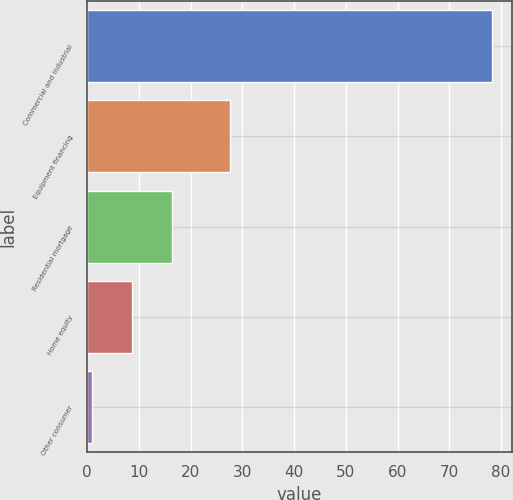Convert chart. <chart><loc_0><loc_0><loc_500><loc_500><bar_chart><fcel>Commercial and industrial<fcel>Equipment financing<fcel>Residential mortgage<fcel>Home equity<fcel>Other consumer<nl><fcel>78.2<fcel>27.6<fcel>16.44<fcel>8.72<fcel>1<nl></chart> 